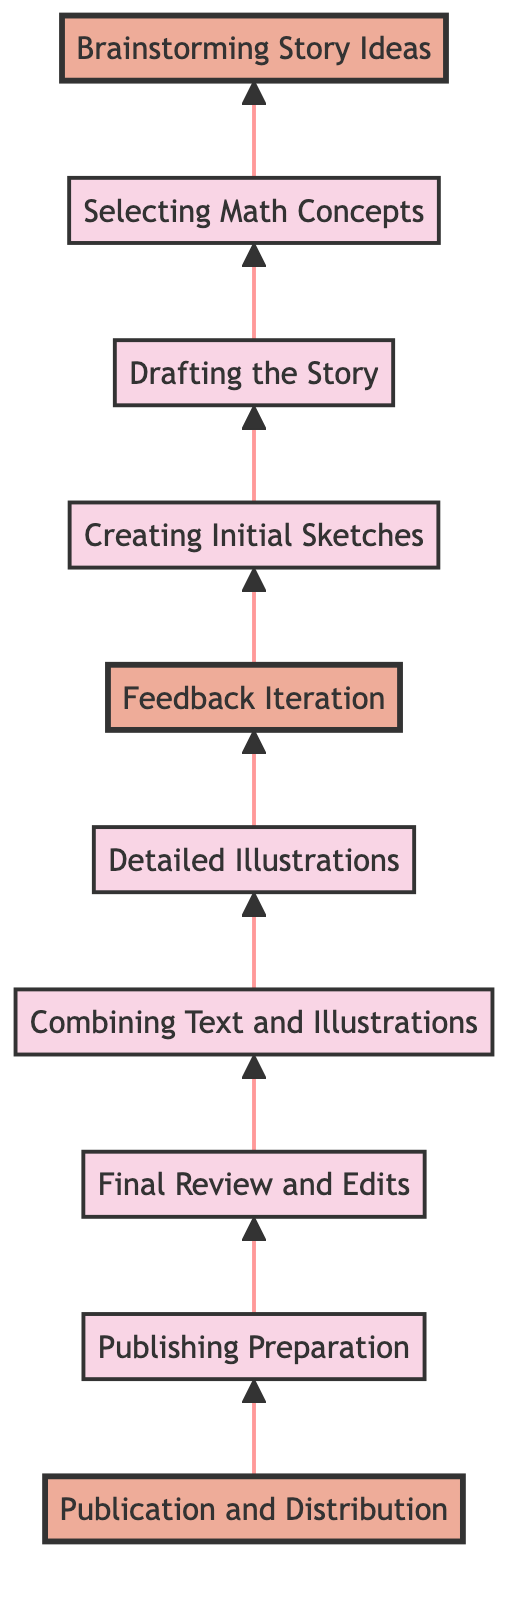What is the first step in the process? The first step, according to the diagram, is "Brainstorming Story Ideas". This is the bottommost element in the flowchart and represents the initial phase of the process.
Answer: Brainstorming Story Ideas How many nodes are there in the diagram? The diagram contains a total of ten nodes, each representing a different step in the process.
Answer: 10 Which step comes after "Creating Initial Sketches"? The step that directly follows "Creating Initial Sketches" in the flowchart is "Feedback Iteration". This can be observed by following the arrows connecting the nodes.
Answer: Feedback Iteration Identify the step that leads to "Final Review and Edits". "Detailed Illustrations" is the step that leads to "Final Review and Edits". This is determined by the upward flow in the diagram where the arrow points from "Detailed Illustrations" to "Final Review and Edits".
Answer: Detailed Illustrations What are the highlighted steps in the diagram? The highlighted steps in the diagram are "Brainstorming Story Ideas", "Feedback Iteration", and "Publication and Distribution". These steps are distinctly marked for emphasis.
Answer: Brainstorming Story Ideas, Feedback Iteration, Publication and Distribution Which step is the last in the flow of the process? The last step in the flow of the process is "Publication and Distribution", as it is the topmost node in the flowchart.
Answer: Publication and Distribution How many steps are between "Drafting the Story" and "Detailed Illustrations"? There are two steps between "Drafting the Story" and "Detailed Illustrations". They are "Creating Initial Sketches" and "Feedback Iteration".
Answer: 2 What is the relationship between "Selecting Math Concepts" and "Drafting the Story"? "Selecting Math Concepts" is the direct predecessor of "Drafting the Story", establishing a sequential relationship where one follows from the other.
Answer: Direct predecessor What is the step that integrates text with illustrations? The step that integrates text with illustrations is "Combining Text and Illustrations", as specified in the diagram.
Answer: Combining Text and Illustrations 